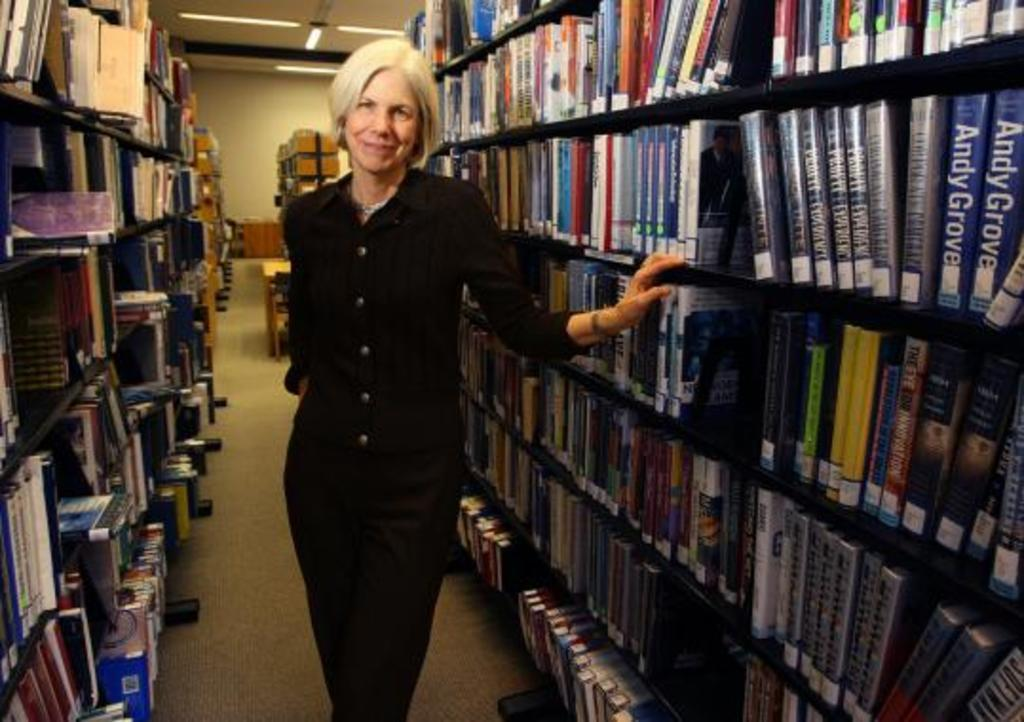<image>
Describe the image concisely. A woman standing in a row of library books with the name Andy Grove visible. 